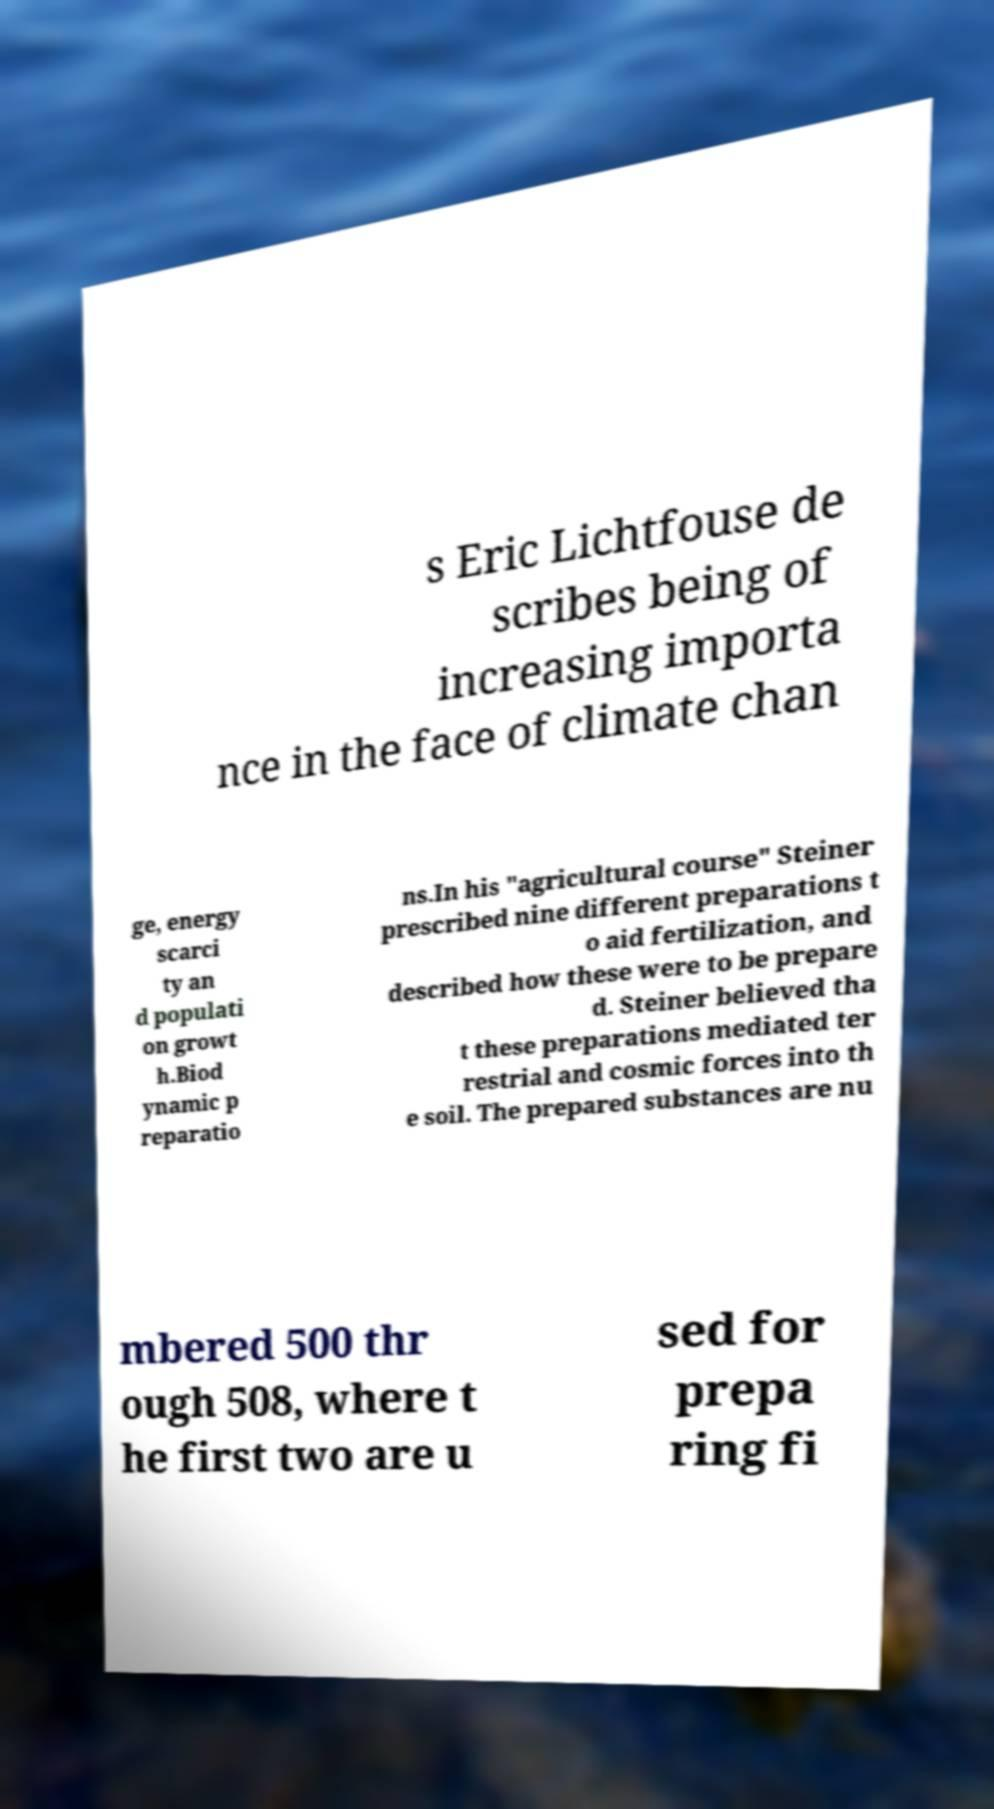Could you assist in decoding the text presented in this image and type it out clearly? s Eric Lichtfouse de scribes being of increasing importa nce in the face of climate chan ge, energy scarci ty an d populati on growt h.Biod ynamic p reparatio ns.In his "agricultural course" Steiner prescribed nine different preparations t o aid fertilization, and described how these were to be prepare d. Steiner believed tha t these preparations mediated ter restrial and cosmic forces into th e soil. The prepared substances are nu mbered 500 thr ough 508, where t he first two are u sed for prepa ring fi 